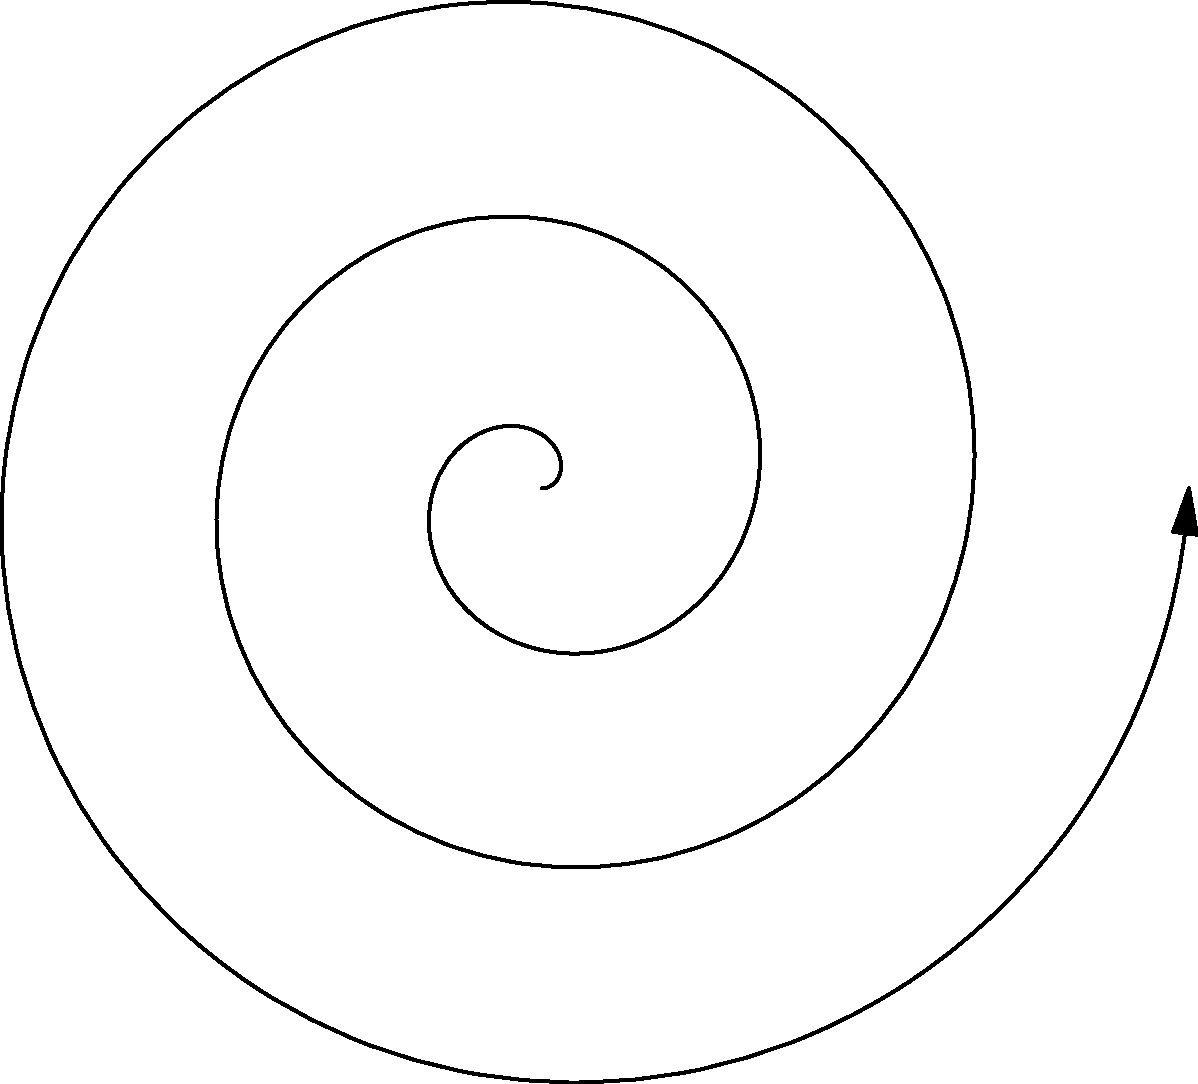In your latest novel, you've depicted the evolution of machine learning algorithms as a spiral in polar coordinates. If the radial distance $r$ is given by the function $r = 0.1t$, where $t$ represents time, and each complete revolution represents a decade of progress, at what time $t$ (in radians) would the spiral reach the point representing Deep Learning? To solve this problem, we need to follow these steps:

1) First, observe that the spiral makes one complete revolution (2π radians) per decade.

2) In the diagram, Deep Learning appears to be at about the 2.75th revolution.

3) To calculate the exact time:
   2.75 revolutions * 2π radians/revolution = 5.5π radians

4) We can verify this by looking at the polar equation:
   $r = 0.1t$
   $x = r\cos(t) = 0.1t\cos(t)$
   $y = r\sin(t) = 0.1t\sin(t)$

5) At $t = 5.5π$:
   $r = 0.1(5.5π) ≈ 1.73$
   This matches the radial distance of the "Deep Learning" point in the diagram.

6) Therefore, the time $t$ at which the spiral reaches the point representing Deep Learning is 5.5π radians.
Answer: 5.5π radians 